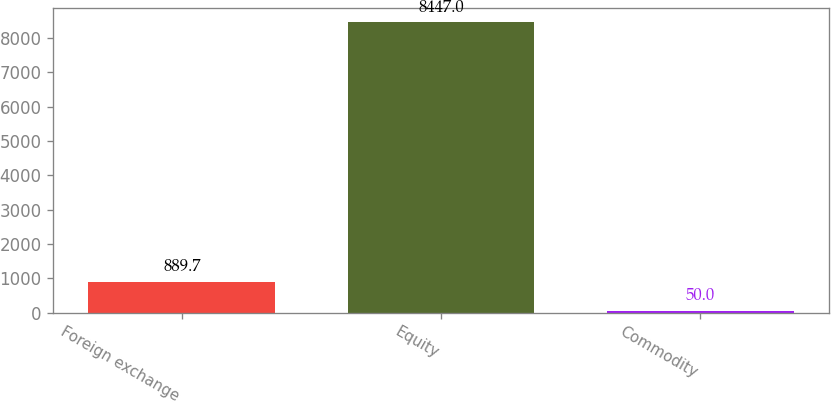Convert chart to OTSL. <chart><loc_0><loc_0><loc_500><loc_500><bar_chart><fcel>Foreign exchange<fcel>Equity<fcel>Commodity<nl><fcel>889.7<fcel>8447<fcel>50<nl></chart> 